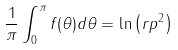Convert formula to latex. <formula><loc_0><loc_0><loc_500><loc_500>\frac { 1 } { \pi } \int _ { 0 } ^ { \pi } f ( \theta ) d \theta = \ln \left ( r p ^ { 2 } \right )</formula> 